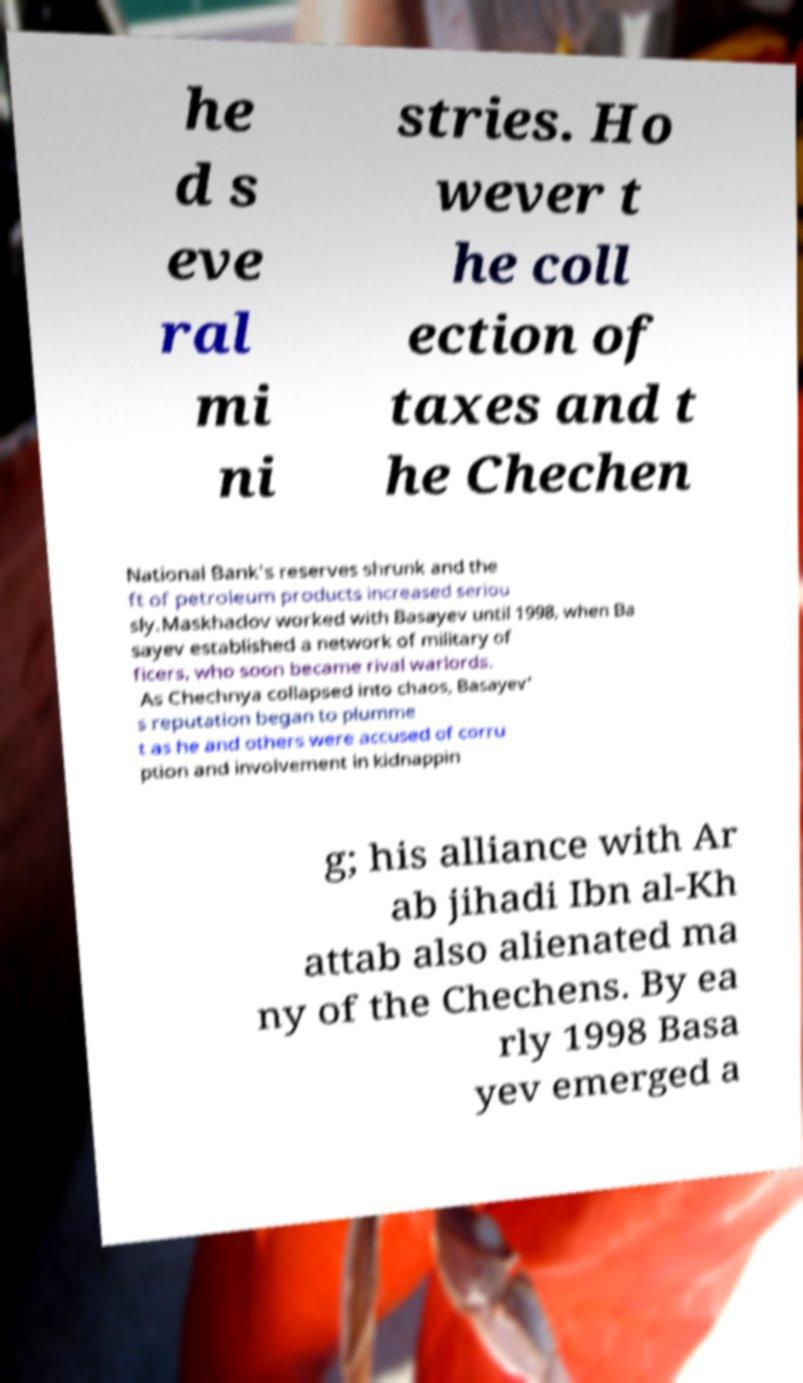Could you assist in decoding the text presented in this image and type it out clearly? he d s eve ral mi ni stries. Ho wever t he coll ection of taxes and t he Chechen National Bank's reserves shrunk and the ft of petroleum products increased seriou sly.Maskhadov worked with Basayev until 1998, when Ba sayev established a network of military of ficers, who soon became rival warlords. As Chechnya collapsed into chaos, Basayev' s reputation began to plumme t as he and others were accused of corru ption and involvement in kidnappin g; his alliance with Ar ab jihadi Ibn al-Kh attab also alienated ma ny of the Chechens. By ea rly 1998 Basa yev emerged a 